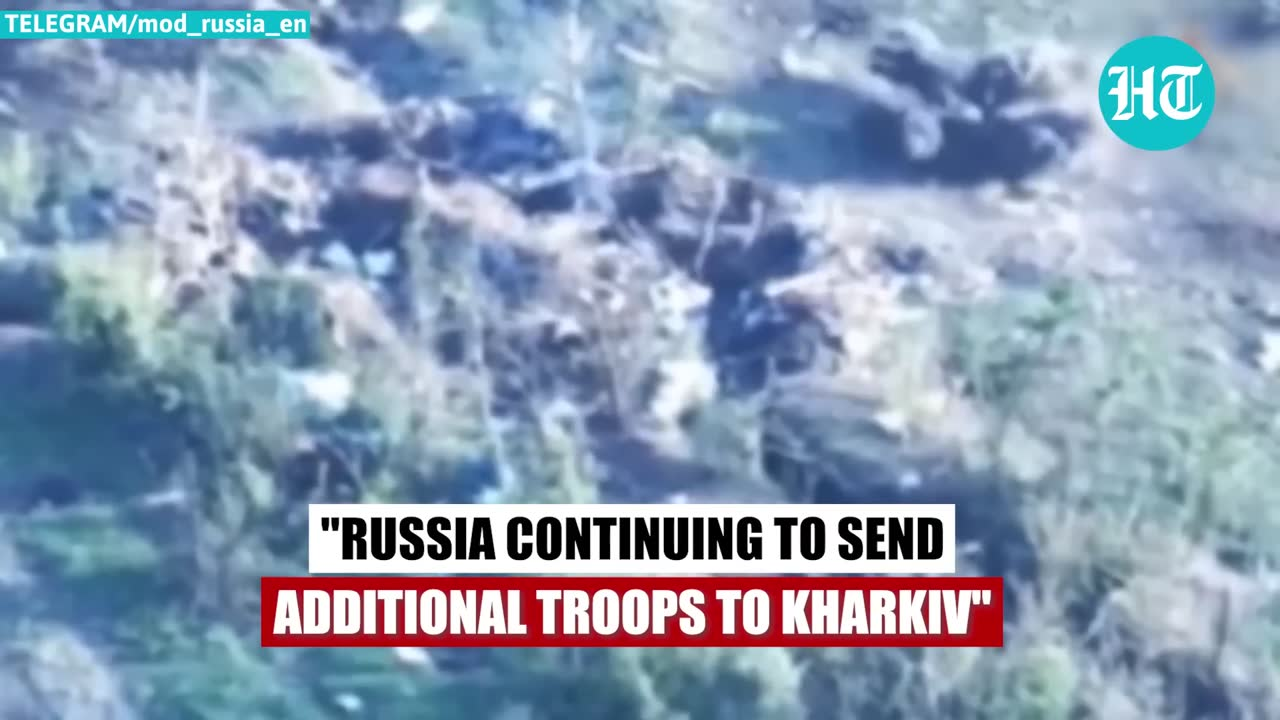describe the img The image appears to be a satellite or aerial view showing a dense urban area with many buildings and structures. The buildings and structures are tightly packed together, indicating a heavily populated area. The colors in the image are muted shades of gray and blue, typical of aerial or satellite imagery. The text overlaid on the image states "RUSSIA CONTINUING TO SEND ADDITIONAL TROOPS TO KHARKIV", suggesting that the area depicted is likely the city of Kharkiv in Ukraine, and that the image may be related to Russia's ongoing military operations in the region. 